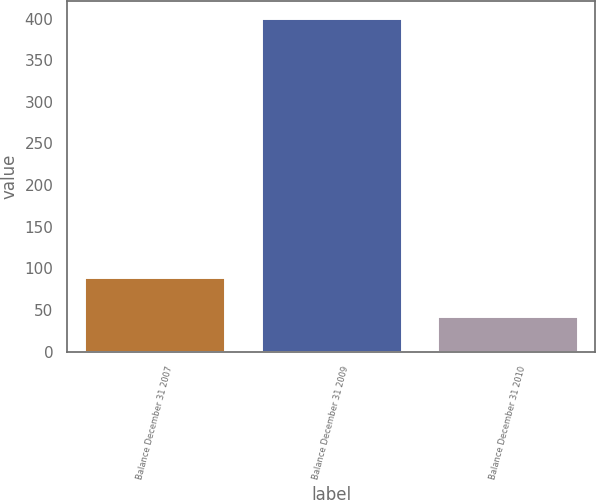Convert chart to OTSL. <chart><loc_0><loc_0><loc_500><loc_500><bar_chart><fcel>Balance December 31 2007<fcel>Balance December 31 2009<fcel>Balance December 31 2010<nl><fcel>90<fcel>401<fcel>43<nl></chart> 